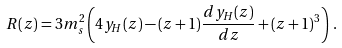<formula> <loc_0><loc_0><loc_500><loc_500>R ( z ) = 3 m _ { s } ^ { 2 } \left ( 4 y _ { H } ( z ) - ( z + 1 ) \frac { d y _ { H } ( z ) } { d z } + ( z + 1 ) ^ { 3 } \right ) \, .</formula> 